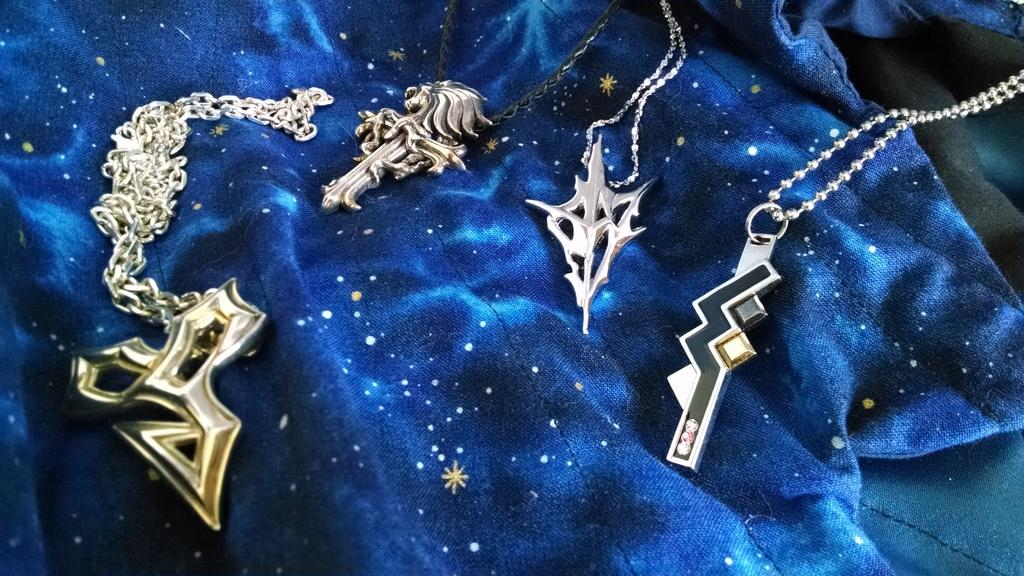What is the main object in the image? There is a pendant in the image. How is the pendant attached to something else? The pendant has chains. What color is the background of the image? The background of the image is blue. What is the rate of the orange in the image? There is no orange present in the image, so it is not possible to determine a rate. 